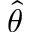<formula> <loc_0><loc_0><loc_500><loc_500>\hat { \theta }</formula> 